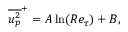Convert formula to latex. <formula><loc_0><loc_0><loc_500><loc_500>\overline { { u _ { p } ^ { 2 } } } ^ { + } = A \ln ( R e _ { \tau } ) + B ,</formula> 